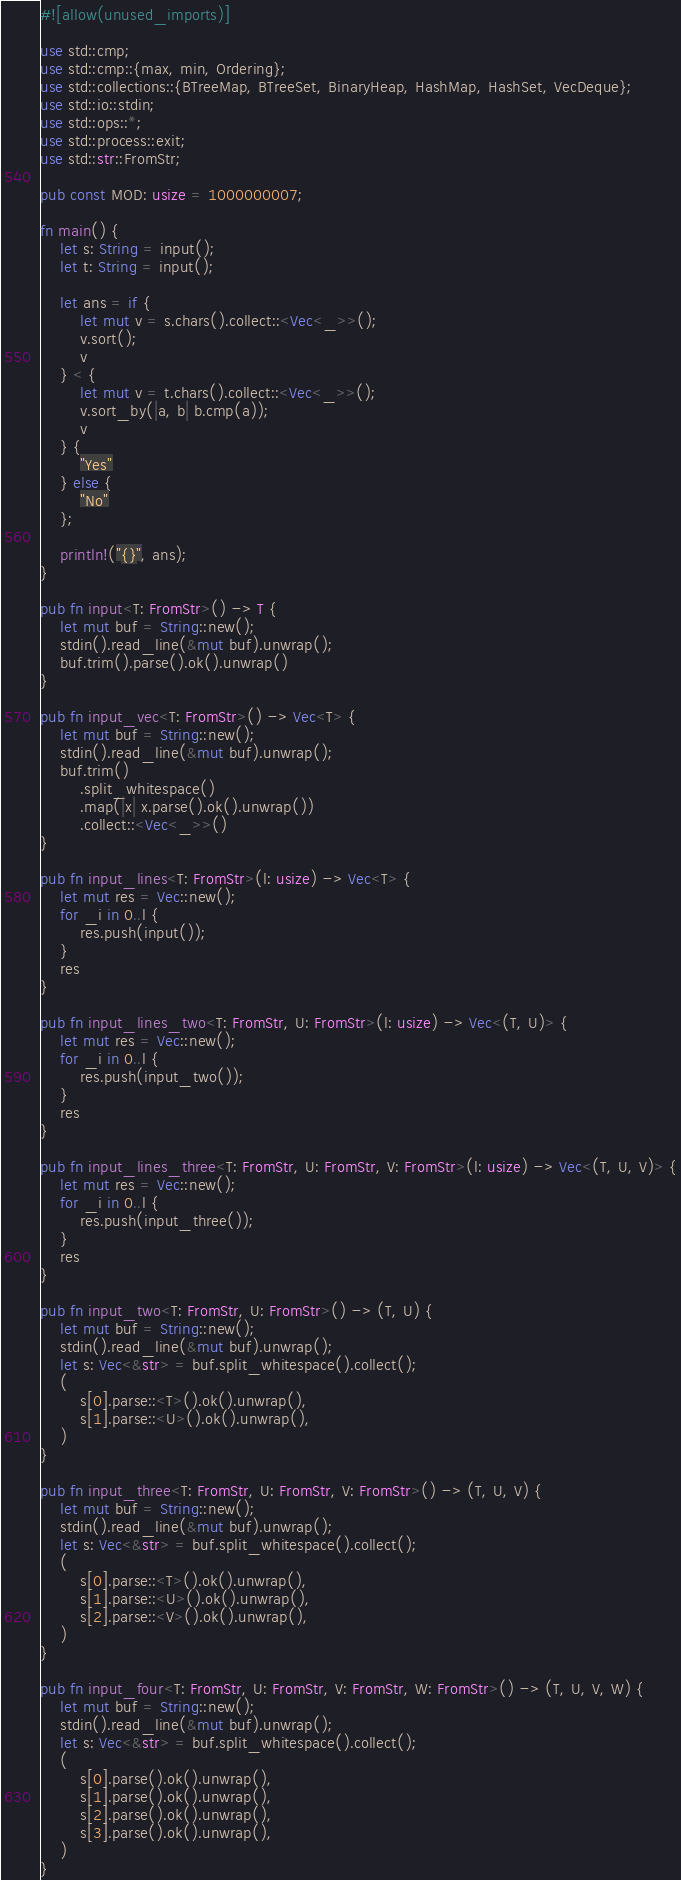Convert code to text. <code><loc_0><loc_0><loc_500><loc_500><_Rust_>#![allow(unused_imports)]

use std::cmp;
use std::cmp::{max, min, Ordering};
use std::collections::{BTreeMap, BTreeSet, BinaryHeap, HashMap, HashSet, VecDeque};
use std::io::stdin;
use std::ops::*;
use std::process::exit;
use std::str::FromStr;

pub const MOD: usize = 1000000007;

fn main() {
    let s: String = input();
    let t: String = input();

    let ans = if {
        let mut v = s.chars().collect::<Vec<_>>();
        v.sort();
        v
    } < {
        let mut v = t.chars().collect::<Vec<_>>();
        v.sort_by(|a, b| b.cmp(a));
        v
    } {
        "Yes"
    } else {
        "No"
    };

    println!("{}", ans);
}

pub fn input<T: FromStr>() -> T {
    let mut buf = String::new();
    stdin().read_line(&mut buf).unwrap();
    buf.trim().parse().ok().unwrap()
}

pub fn input_vec<T: FromStr>() -> Vec<T> {
    let mut buf = String::new();
    stdin().read_line(&mut buf).unwrap();
    buf.trim()
        .split_whitespace()
        .map(|x| x.parse().ok().unwrap())
        .collect::<Vec<_>>()
}

pub fn input_lines<T: FromStr>(l: usize) -> Vec<T> {
    let mut res = Vec::new();
    for _i in 0..l {
        res.push(input());
    }
    res
}

pub fn input_lines_two<T: FromStr, U: FromStr>(l: usize) -> Vec<(T, U)> {
    let mut res = Vec::new();
    for _i in 0..l {
        res.push(input_two());
    }
    res
}

pub fn input_lines_three<T: FromStr, U: FromStr, V: FromStr>(l: usize) -> Vec<(T, U, V)> {
    let mut res = Vec::new();
    for _i in 0..l {
        res.push(input_three());
    }
    res
}

pub fn input_two<T: FromStr, U: FromStr>() -> (T, U) {
    let mut buf = String::new();
    stdin().read_line(&mut buf).unwrap();
    let s: Vec<&str> = buf.split_whitespace().collect();
    (
        s[0].parse::<T>().ok().unwrap(),
        s[1].parse::<U>().ok().unwrap(),
    )
}

pub fn input_three<T: FromStr, U: FromStr, V: FromStr>() -> (T, U, V) {
    let mut buf = String::new();
    stdin().read_line(&mut buf).unwrap();
    let s: Vec<&str> = buf.split_whitespace().collect();
    (
        s[0].parse::<T>().ok().unwrap(),
        s[1].parse::<U>().ok().unwrap(),
        s[2].parse::<V>().ok().unwrap(),
    )
}

pub fn input_four<T: FromStr, U: FromStr, V: FromStr, W: FromStr>() -> (T, U, V, W) {
    let mut buf = String::new();
    stdin().read_line(&mut buf).unwrap();
    let s: Vec<&str> = buf.split_whitespace().collect();
    (
        s[0].parse().ok().unwrap(),
        s[1].parse().ok().unwrap(),
        s[2].parse().ok().unwrap(),
        s[3].parse().ok().unwrap(),
    )
}
</code> 